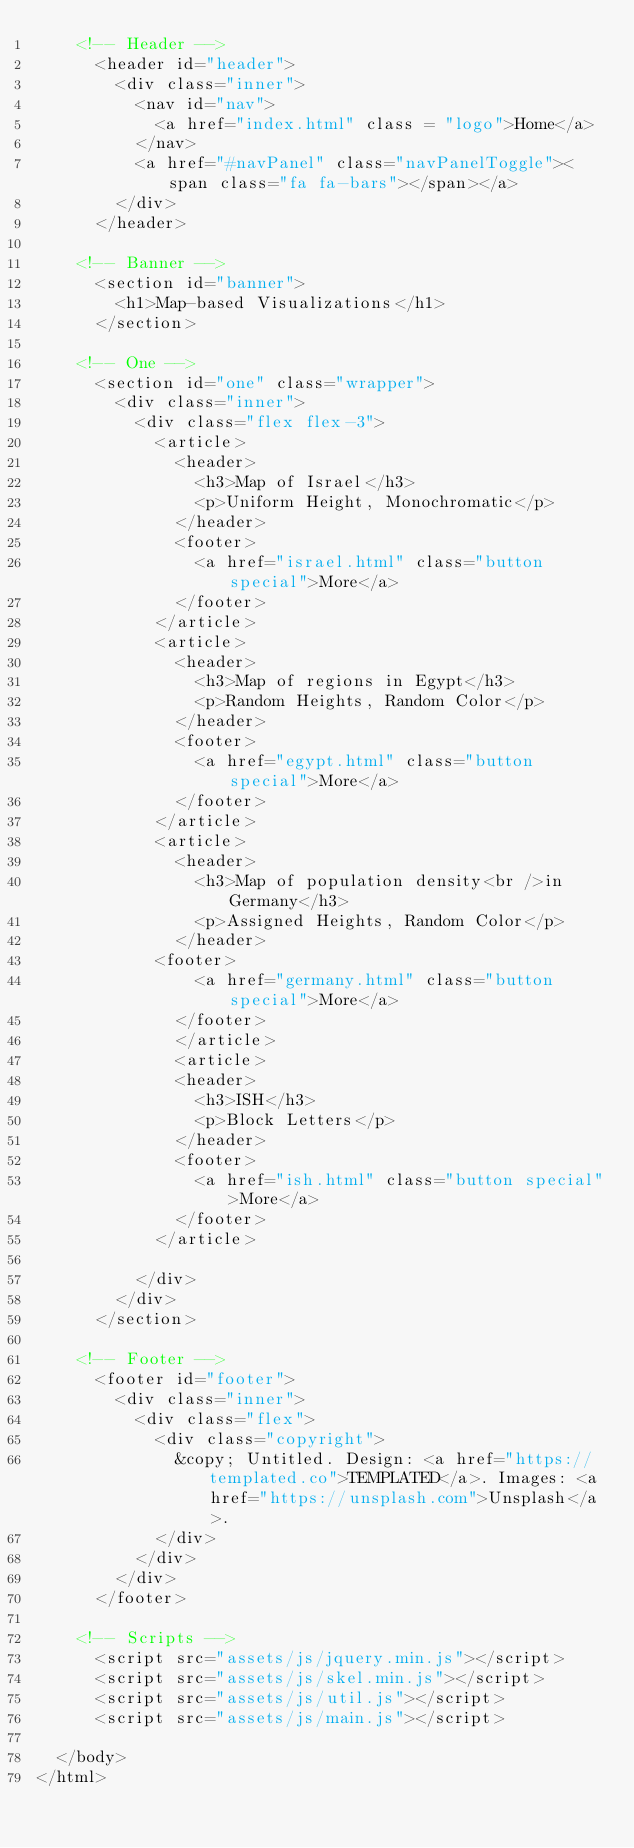Convert code to text. <code><loc_0><loc_0><loc_500><loc_500><_HTML_>		<!-- Header -->
			<header id="header">
				<div class="inner">
					<nav id="nav">
						<a href="index.html" class = "logo">Home</a>
					</nav>
					<a href="#navPanel" class="navPanelToggle"><span class="fa fa-bars"></span></a>
				</div>
			</header>

		<!-- Banner -->
			<section id="banner">
				<h1>Map-based Visualizations</h1>
			</section>

		<!-- One -->
			<section id="one" class="wrapper">
				<div class="inner">
					<div class="flex flex-3">
						<article>
							<header>
								<h3>Map of Israel</h3>
								<p>Uniform Height, Monochromatic</p>
							</header>
							<footer>
								<a href="israel.html" class="button special">More</a>
							</footer>
						</article>
						<article>
							<header>
								<h3>Map of regions in Egypt</h3>
								<p>Random Heights, Random Color</p>
							</header>
							<footer>
								<a href="egypt.html" class="button special">More</a>
							</footer>
						</article>
						<article>
							<header>
								<h3>Map of population density<br />in Germany</h3>
								<p>Assigned Heights, Random Color</p>
							</header>
						<footer>
								<a href="germany.html" class="button special">More</a>
							</footer>
							</article>
							<article>
							<header>
								<h3>ISH</h3>
								<p>Block Letters</p>
							</header>
							<footer>
								<a href="ish.html" class="button special">More</a>
							</footer>
						</article>
						
					</div>
				</div>
			</section>

		<!-- Footer -->
			<footer id="footer">
				<div class="inner">
					<div class="flex">
						<div class="copyright">
							&copy; Untitled. Design: <a href="https://templated.co">TEMPLATED</a>. Images: <a href="https://unsplash.com">Unsplash</a>.
						</div>
					</div>
				</div>
			</footer>

		<!-- Scripts -->
			<script src="assets/js/jquery.min.js"></script>
			<script src="assets/js/skel.min.js"></script>
			<script src="assets/js/util.js"></script>
			<script src="assets/js/main.js"></script>

	</body>
</html>
</code> 